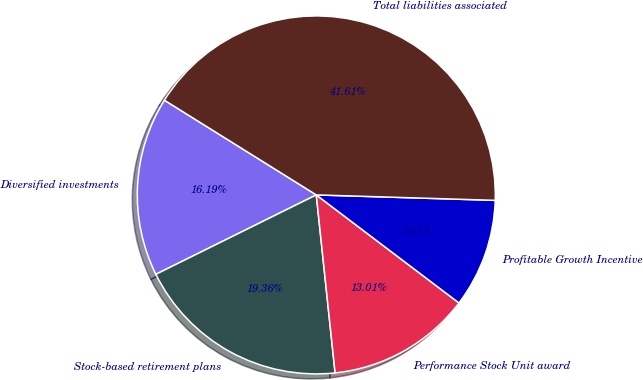Convert chart. <chart><loc_0><loc_0><loc_500><loc_500><pie_chart><fcel>Diversified investments<fcel>Stock-based retirement plans<fcel>Performance Stock Unit award<fcel>Profitable Growth Incentive<fcel>Total liabilities associated<nl><fcel>16.19%<fcel>19.36%<fcel>13.01%<fcel>9.83%<fcel>41.61%<nl></chart> 